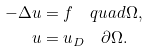<formula> <loc_0><loc_0><loc_500><loc_500>- \Delta u & = f \quad q u a d \Omega , \\ u & = u _ { D } \quad \partial \Omega .</formula> 